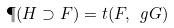Convert formula to latex. <formula><loc_0><loc_0><loc_500><loc_500>\P ( H \supset F ) = t ( F , \ g G )</formula> 